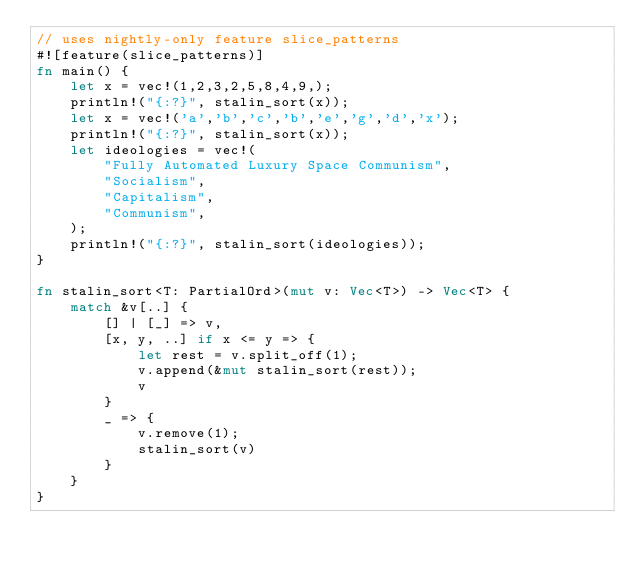Convert code to text. <code><loc_0><loc_0><loc_500><loc_500><_Rust_>// uses nightly-only feature slice_patterns
#![feature(slice_patterns)]
fn main() {
    let x = vec!(1,2,3,2,5,8,4,9,);
    println!("{:?}", stalin_sort(x));
    let x = vec!('a','b','c','b','e','g','d','x');
    println!("{:?}", stalin_sort(x));
    let ideologies = vec!(
        "Fully Automated Luxury Space Communism",
        "Socialism",
        "Capitalism",
        "Communism",
    );
    println!("{:?}", stalin_sort(ideologies));
}

fn stalin_sort<T: PartialOrd>(mut v: Vec<T>) -> Vec<T> {
    match &v[..] {
        [] | [_] => v,
        [x, y, ..] if x <= y => {
            let rest = v.split_off(1);
            v.append(&mut stalin_sort(rest));
            v
        }
        _ => {
            v.remove(1);
            stalin_sort(v)
        }
    }
}
</code> 